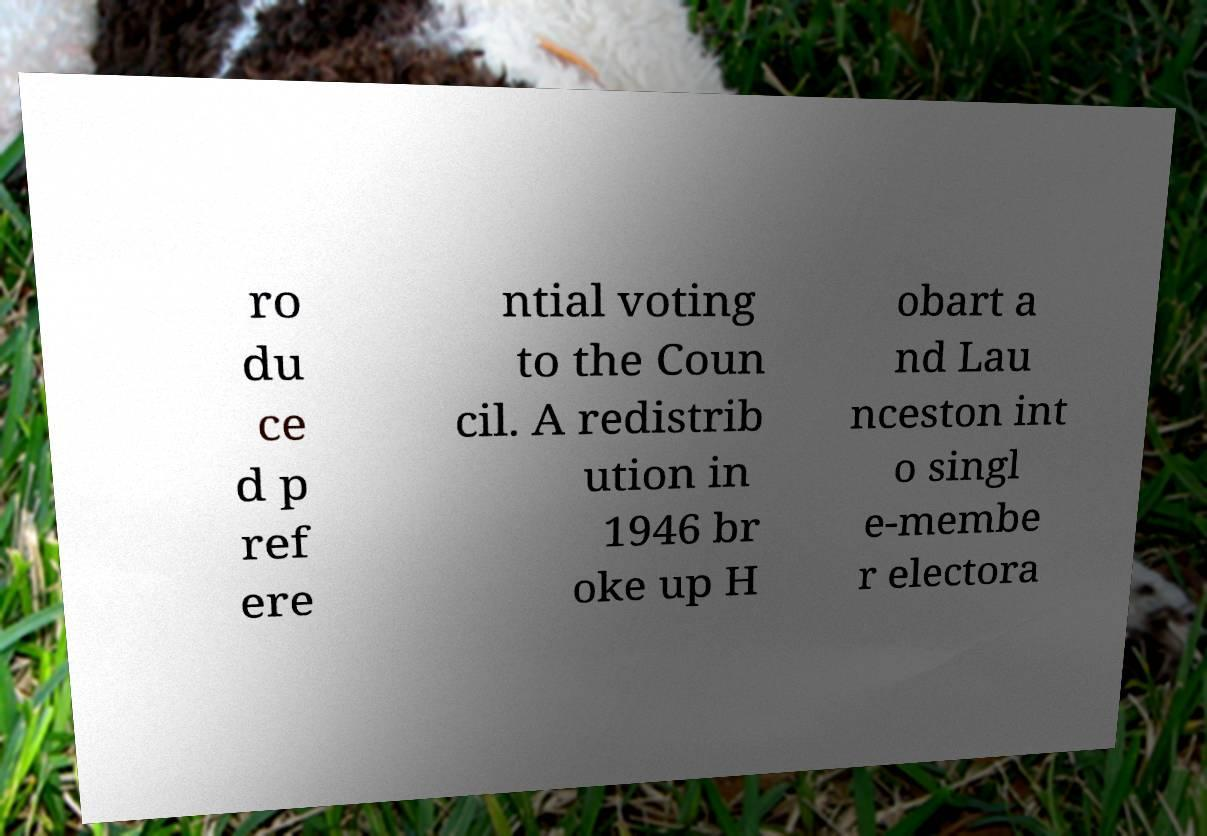What messages or text are displayed in this image? I need them in a readable, typed format. ro du ce d p ref ere ntial voting to the Coun cil. A redistrib ution in 1946 br oke up H obart a nd Lau nceston int o singl e-membe r electora 